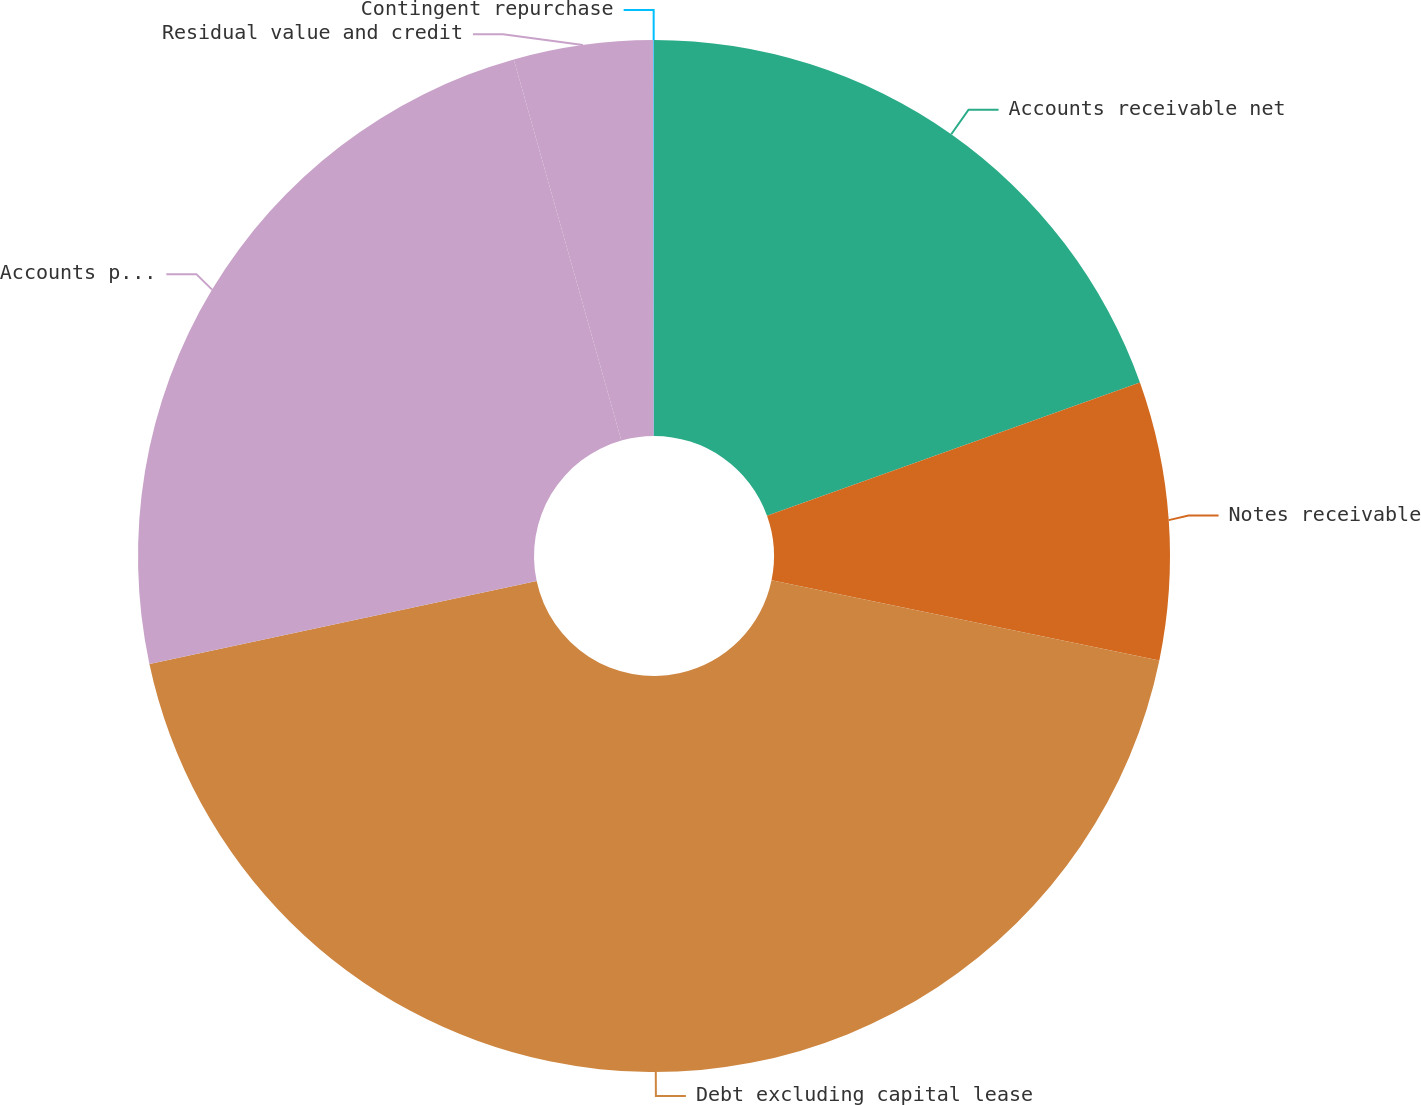Convert chart to OTSL. <chart><loc_0><loc_0><loc_500><loc_500><pie_chart><fcel>Accounts receivable net<fcel>Notes receivable<fcel>Debt excluding capital lease<fcel>Accounts payable<fcel>Residual value and credit<fcel>Contingent repurchase<nl><fcel>19.54%<fcel>8.7%<fcel>43.4%<fcel>23.97%<fcel>4.36%<fcel>0.02%<nl></chart> 